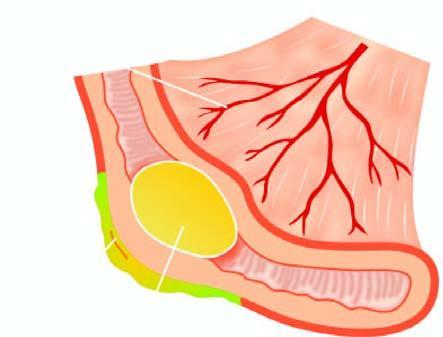did gross appearance of longitudinally open appendix showing impacted faecolith in the lumen and exudate on the serosa?
Answer the question using a single word or phrase. Yes 